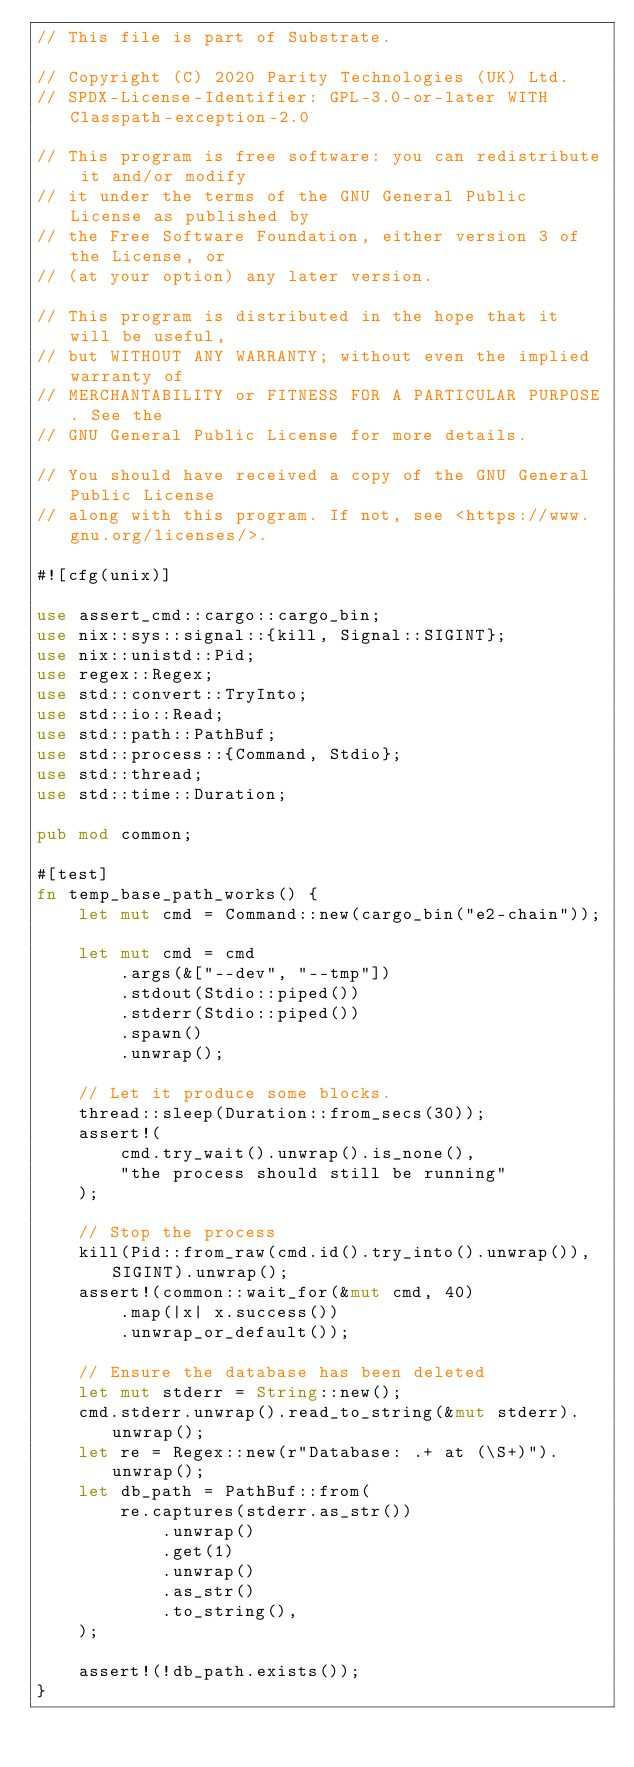<code> <loc_0><loc_0><loc_500><loc_500><_Rust_>// This file is part of Substrate.

// Copyright (C) 2020 Parity Technologies (UK) Ltd.
// SPDX-License-Identifier: GPL-3.0-or-later WITH Classpath-exception-2.0

// This program is free software: you can redistribute it and/or modify
// it under the terms of the GNU General Public License as published by
// the Free Software Foundation, either version 3 of the License, or
// (at your option) any later version.

// This program is distributed in the hope that it will be useful,
// but WITHOUT ANY WARRANTY; without even the implied warranty of
// MERCHANTABILITY or FITNESS FOR A PARTICULAR PURPOSE. See the
// GNU General Public License for more details.

// You should have received a copy of the GNU General Public License
// along with this program. If not, see <https://www.gnu.org/licenses/>.

#![cfg(unix)]

use assert_cmd::cargo::cargo_bin;
use nix::sys::signal::{kill, Signal::SIGINT};
use nix::unistd::Pid;
use regex::Regex;
use std::convert::TryInto;
use std::io::Read;
use std::path::PathBuf;
use std::process::{Command, Stdio};
use std::thread;
use std::time::Duration;

pub mod common;

#[test]
fn temp_base_path_works() {
    let mut cmd = Command::new(cargo_bin("e2-chain"));

    let mut cmd = cmd
        .args(&["--dev", "--tmp"])
        .stdout(Stdio::piped())
        .stderr(Stdio::piped())
        .spawn()
        .unwrap();

    // Let it produce some blocks.
    thread::sleep(Duration::from_secs(30));
    assert!(
        cmd.try_wait().unwrap().is_none(),
        "the process should still be running"
    );

    // Stop the process
    kill(Pid::from_raw(cmd.id().try_into().unwrap()), SIGINT).unwrap();
    assert!(common::wait_for(&mut cmd, 40)
        .map(|x| x.success())
        .unwrap_or_default());

    // Ensure the database has been deleted
    let mut stderr = String::new();
    cmd.stderr.unwrap().read_to_string(&mut stderr).unwrap();
    let re = Regex::new(r"Database: .+ at (\S+)").unwrap();
    let db_path = PathBuf::from(
        re.captures(stderr.as_str())
            .unwrap()
            .get(1)
            .unwrap()
            .as_str()
            .to_string(),
    );

    assert!(!db_path.exists());
}
</code> 